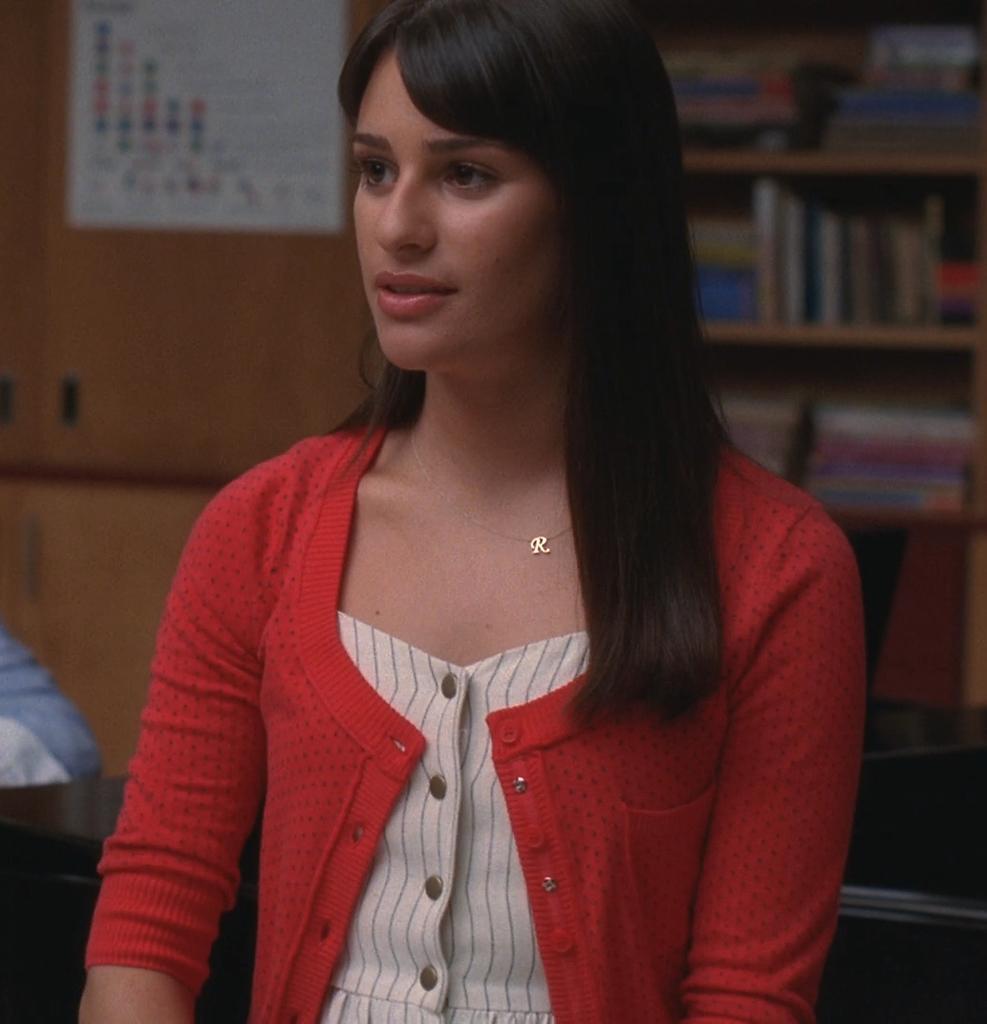How would you summarize this image in a sentence or two? In this image we can see a woman. In the background there are books arranged in the shelves and a paper pasted on the cupboard. 